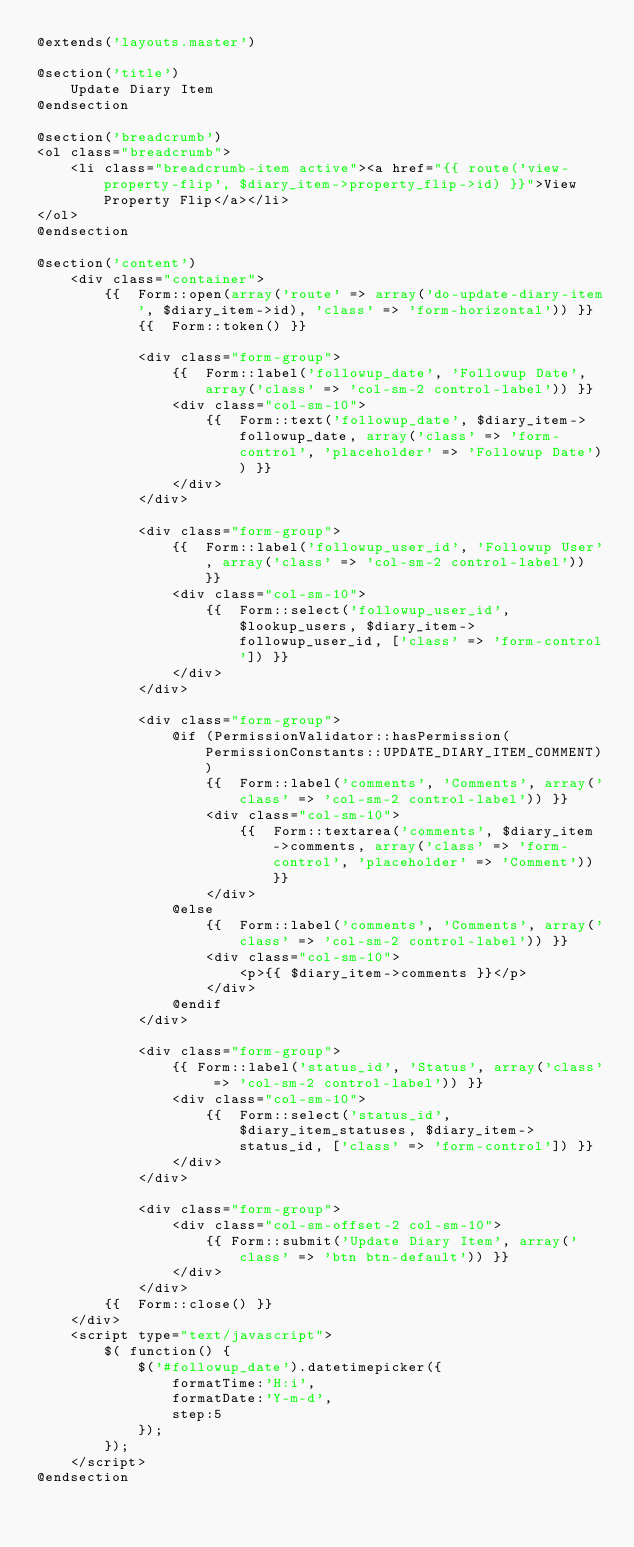Convert code to text. <code><loc_0><loc_0><loc_500><loc_500><_PHP_>@extends('layouts.master')

@section('title')
	Update Diary Item
@endsection

@section('breadcrumb')
<ol class="breadcrumb">
	<li class="breadcrumb-item active"><a href="{{ route('view-property-flip', $diary_item->property_flip->id) }}">View Property Flip</a></li>
</ol>
@endsection

@section('content')
	<div class="container">
		{{  Form::open(array('route' => array('do-update-diary-item', $diary_item->id), 'class' => 'form-horizontal')) }}
			{{  Form::token() }}
			
			<div class="form-group">
				{{  Form::label('followup_date', 'Followup Date', array('class' => 'col-sm-2 control-label')) }}
				<div class="col-sm-10">
					{{  Form::text('followup_date', $diary_item->followup_date, array('class' => 'form-control', 'placeholder' => 'Followup Date')) }}
				</div>
			</div>
			
			<div class="form-group">
				{{  Form::label('followup_user_id', 'Followup User', array('class' => 'col-sm-2 control-label')) }}
				<div class="col-sm-10">
					{{  Form::select('followup_user_id', $lookup_users, $diary_item->followup_user_id, ['class' => 'form-control']) }}
				</div>
			</div>
			
			<div class="form-group">
				@if (PermissionValidator::hasPermission(PermissionConstants::UPDATE_DIARY_ITEM_COMMENT))
					{{  Form::label('comments', 'Comments', array('class' => 'col-sm-2 control-label')) }}
					<div class="col-sm-10">
						{{  Form::textarea('comments', $diary_item->comments, array('class' => 'form-control', 'placeholder' => 'Comment')) }}
					</div>
				@else
					{{  Form::label('comments', 'Comments', array('class' => 'col-sm-2 control-label')) }}
					<div class="col-sm-10">
						<p>{{ $diary_item->comments }}</p>
					</div>
				@endif
			</div>
			
			<div class="form-group">
				{{ Form::label('status_id', 'Status', array('class' => 'col-sm-2 control-label')) }}
				<div class="col-sm-10">
					{{  Form::select('status_id', $diary_item_statuses, $diary_item->status_id, ['class' => 'form-control']) }}
				</div>
			</div>
			
			<div class="form-group">
				<div class="col-sm-offset-2 col-sm-10">
					{{ Form::submit('Update Diary Item', array('class' => 'btn btn-default')) }}
				</div>
			</div>
		{{  Form::close() }}
	</div>
	<script type="text/javascript">
		$( function() {
			$('#followup_date').datetimepicker({
				formatTime:'H:i',
				formatDate:'Y-m-d',
				step:5
			});
		});
	</script>
@endsection</code> 